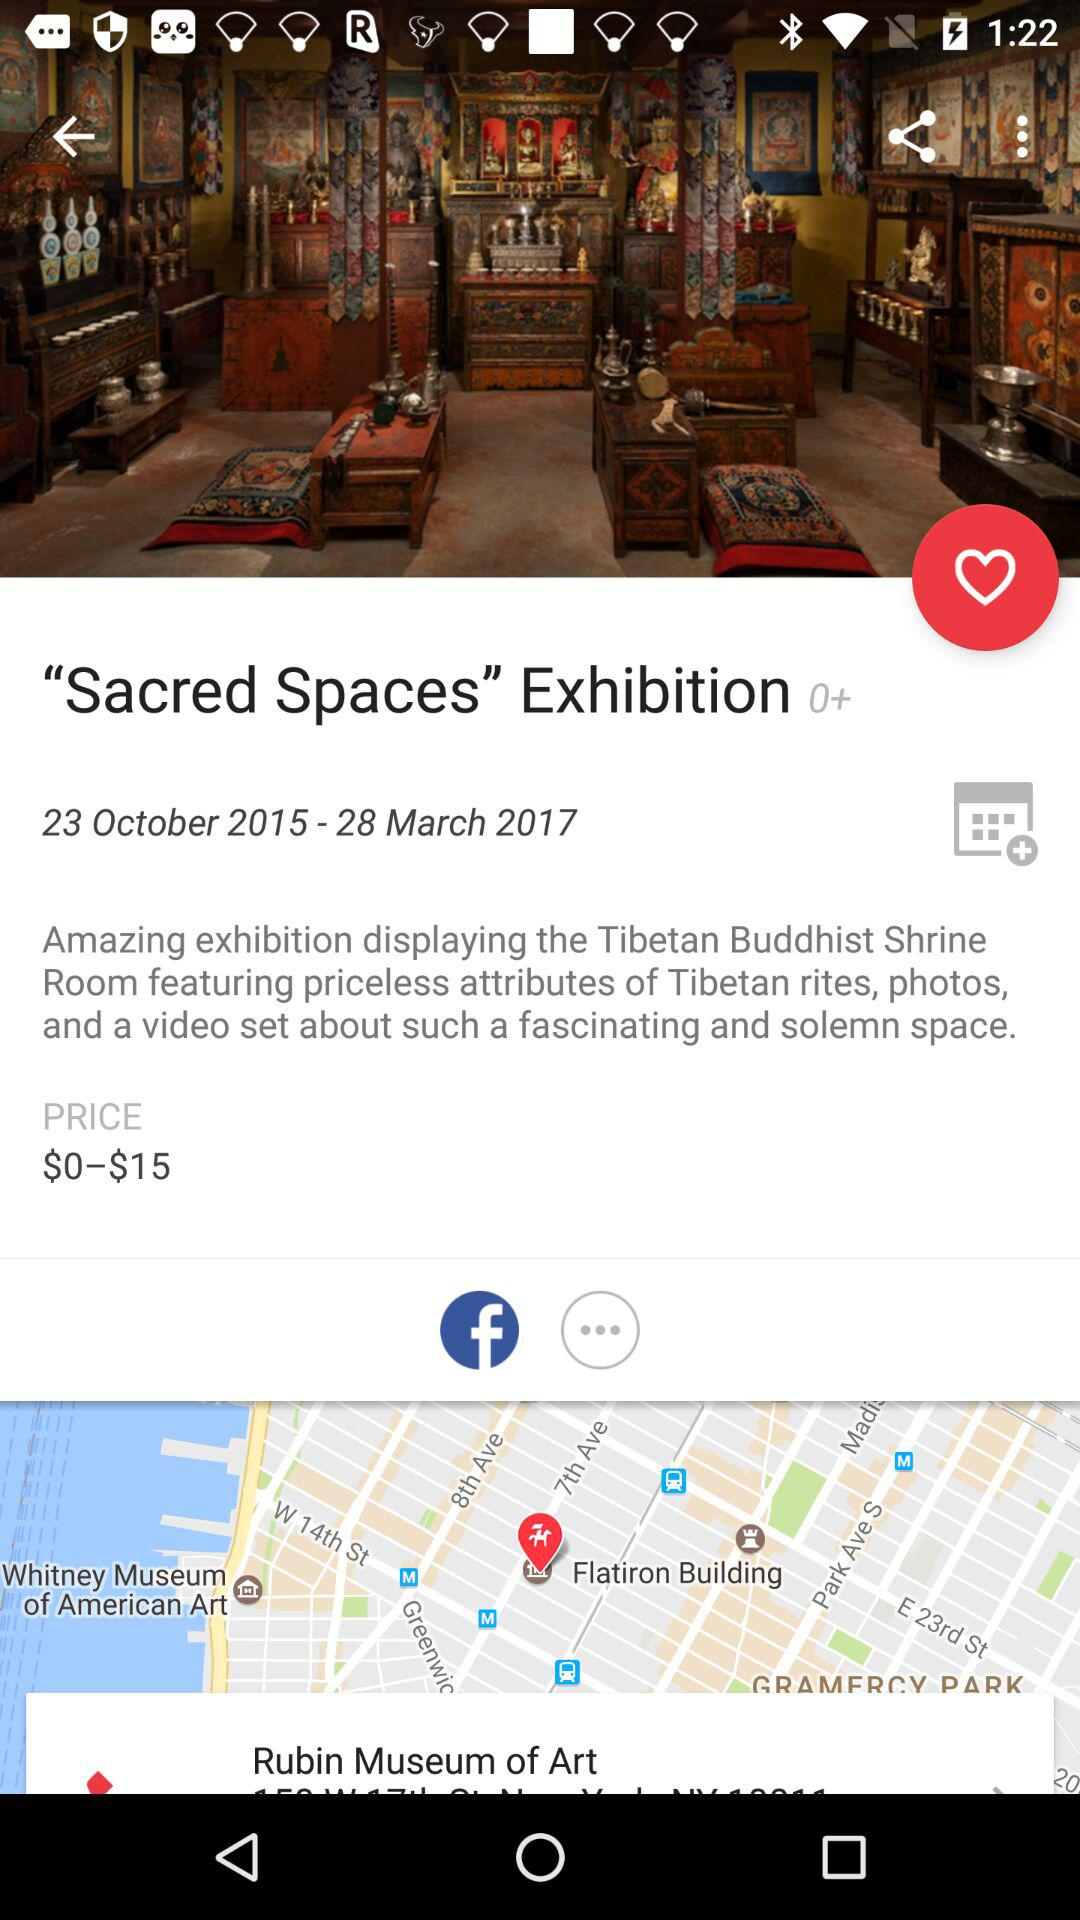What is the name of the exhibition? The name of the exhibition is Sacred Spaces. 